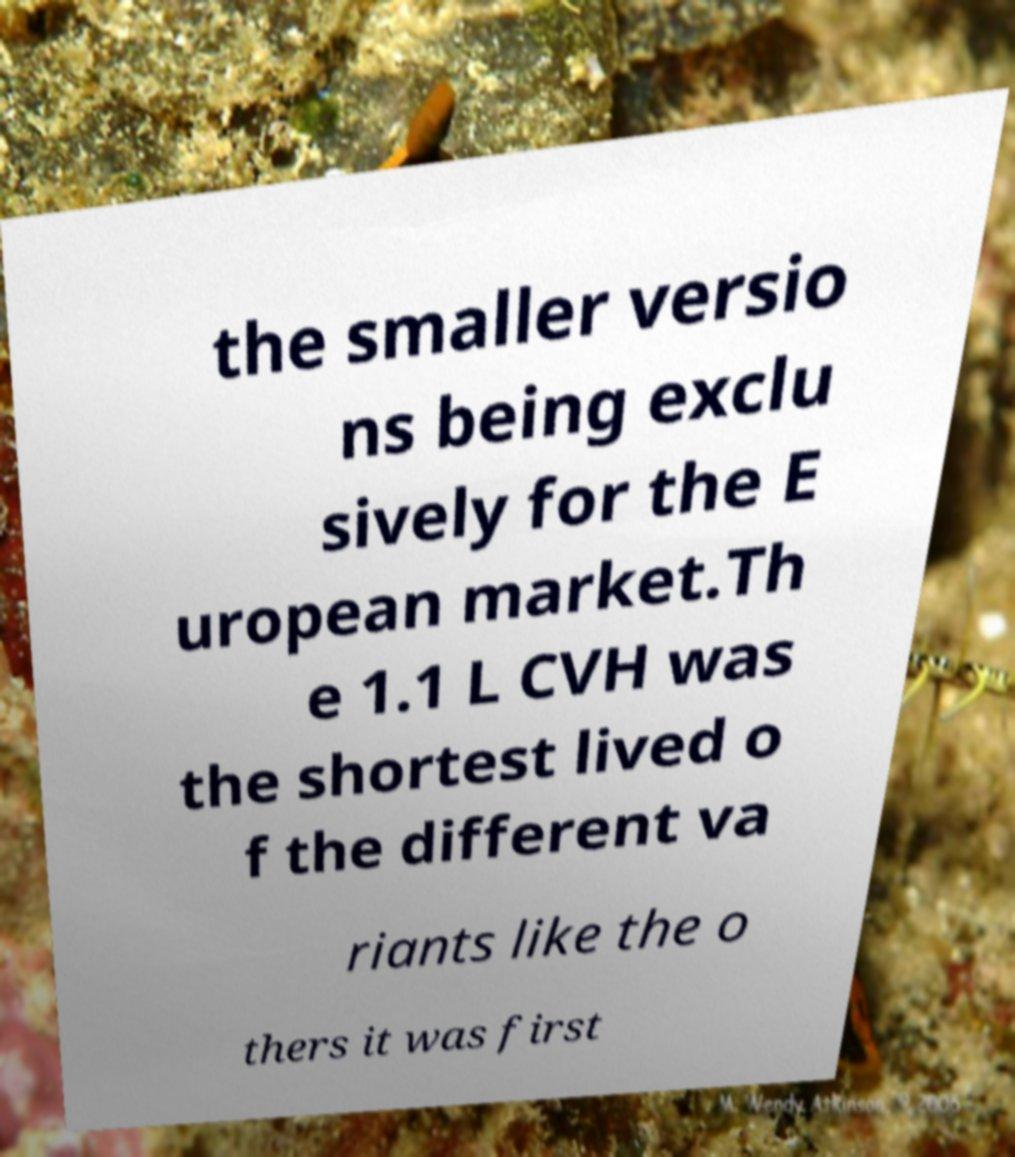For documentation purposes, I need the text within this image transcribed. Could you provide that? the smaller versio ns being exclu sively for the E uropean market.Th e 1.1 L CVH was the shortest lived o f the different va riants like the o thers it was first 